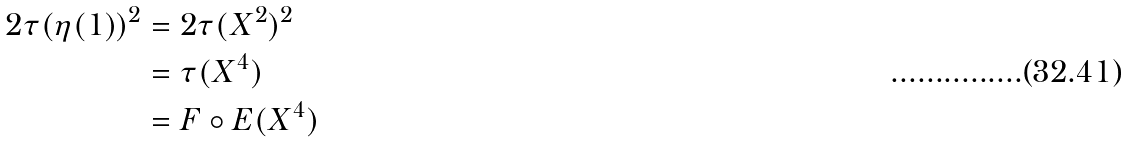Convert formula to latex. <formula><loc_0><loc_0><loc_500><loc_500>2 \tau ( \eta ( 1 ) ) ^ { 2 } & = 2 \tau ( X ^ { 2 } ) ^ { 2 } \\ & = \tau ( X ^ { 4 } ) \\ & = F \circ E ( X ^ { 4 } )</formula> 